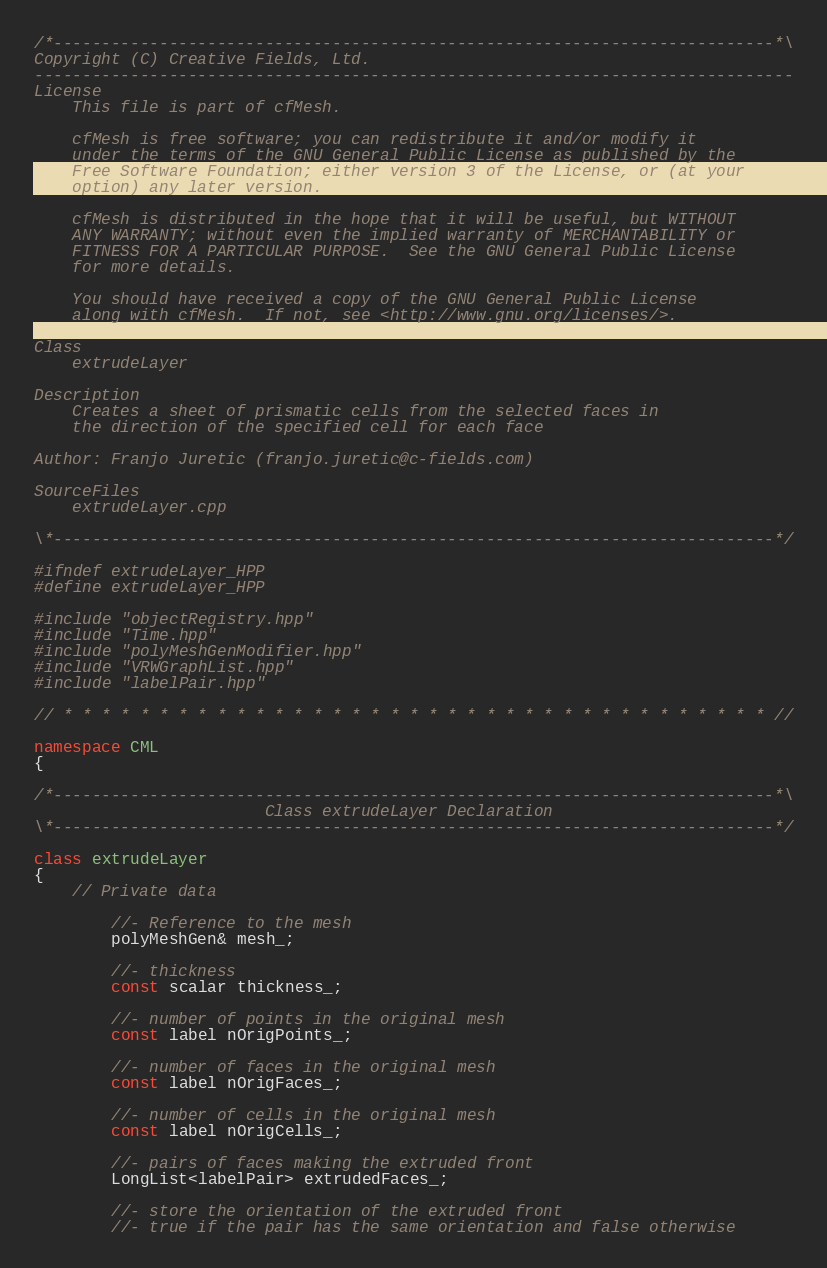Convert code to text. <code><loc_0><loc_0><loc_500><loc_500><_C++_>/*---------------------------------------------------------------------------*\
Copyright (C) Creative Fields, Ltd.
-------------------------------------------------------------------------------
License
    This file is part of cfMesh.

    cfMesh is free software; you can redistribute it and/or modify it
    under the terms of the GNU General Public License as published by the
    Free Software Foundation; either version 3 of the License, or (at your
    option) any later version.

    cfMesh is distributed in the hope that it will be useful, but WITHOUT
    ANY WARRANTY; without even the implied warranty of MERCHANTABILITY or
    FITNESS FOR A PARTICULAR PURPOSE.  See the GNU General Public License
    for more details.

    You should have received a copy of the GNU General Public License
    along with cfMesh.  If not, see <http://www.gnu.org/licenses/>.

Class
    extrudeLayer

Description
    Creates a sheet of prismatic cells from the selected faces in
    the direction of the specified cell for each face

Author: Franjo Juretic (franjo.juretic@c-fields.com)

SourceFiles
    extrudeLayer.cpp

\*---------------------------------------------------------------------------*/

#ifndef extrudeLayer_HPP
#define extrudeLayer_HPP

#include "objectRegistry.hpp"
#include "Time.hpp"
#include "polyMeshGenModifier.hpp"
#include "VRWGraphList.hpp"
#include "labelPair.hpp"

// * * * * * * * * * * * * * * * * * * * * * * * * * * * * * * * * * * * * * //

namespace CML
{

/*---------------------------------------------------------------------------*\
                        Class extrudeLayer Declaration
\*---------------------------------------------------------------------------*/

class extrudeLayer
{
    // Private data

        //- Reference to the mesh
        polyMeshGen& mesh_;

        //- thickness
        const scalar thickness_;

        //- number of points in the original mesh
        const label nOrigPoints_;

        //- number of faces in the original mesh
        const label nOrigFaces_;

        //- number of cells in the original mesh
        const label nOrigCells_;

        //- pairs of faces making the extruded front
        LongList<labelPair> extrudedFaces_;

        //- store the orientation of the extruded front
        //- true if the pair has the same orientation and false otherwise</code> 